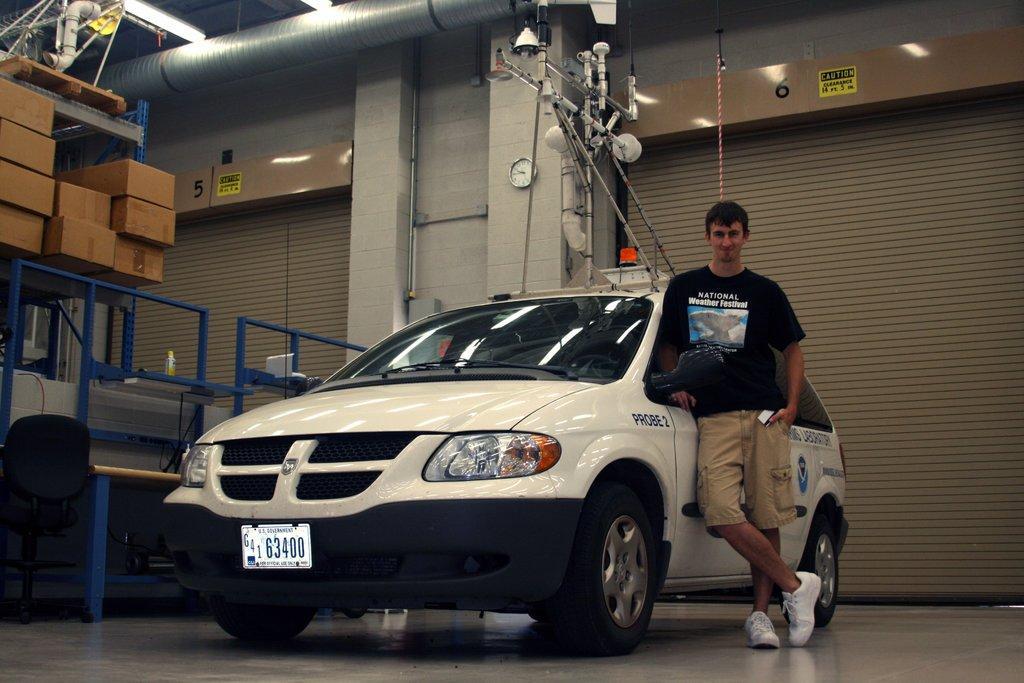Please provide a concise description of this image. In the image in the center we can see one car and one person standing and he is smiling,which we can see on his face. In the background we can see wall,wall clock,tools,shutters,sign boards,boxes,fence,bottle,pipes,lights,vehicle,rope and few other objects. 